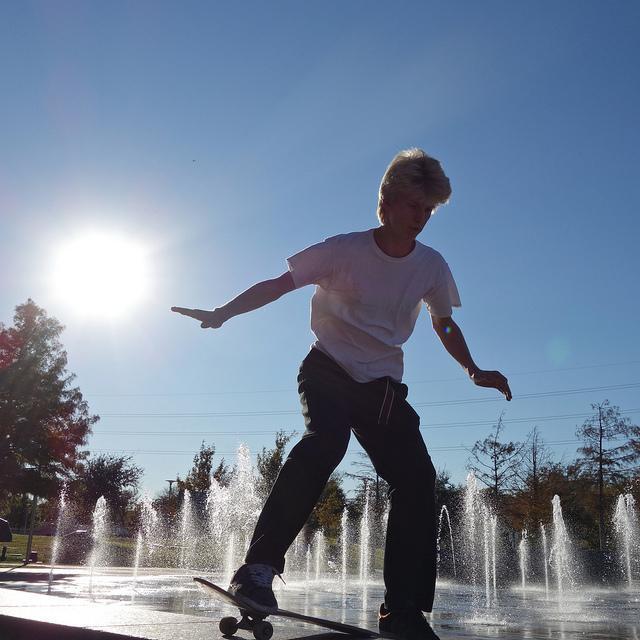How many people are there?
Give a very brief answer. 1. How many airplanes are pictured?
Give a very brief answer. 0. 